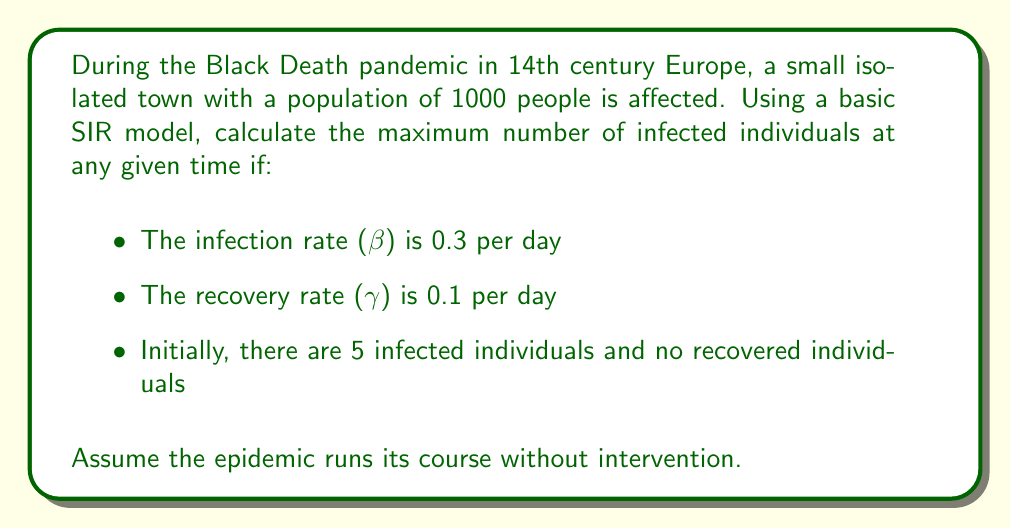Can you solve this math problem? To solve this problem, we'll use the SIR model equations and find the maximum number of infected individuals. Let's break it down step-by-step:

1) First, recall the SIR model equations:

   $$\frac{dS}{dt} = -\beta SI$$
   $$\frac{dI}{dt} = \beta SI - \gamma I$$
   $$\frac{dR}{dt} = \gamma I$$

2) The maximum number of infected individuals occurs when $\frac{dI}{dt} = 0$. At this point:

   $$\beta SI - \gamma I = 0$$

3) Solving for S:

   $$\beta S = \gamma$$
   $$S = \frac{\gamma}{\beta} = \frac{0.1}{0.3} = \frac{1}{3}$$

4) This means the maximum number of infected occurs when 1/3 of the initial population is susceptible.

5) We can use the conservation of population: $S + I + R = N$ (total population)

   At the start: $S_0 = 995$, $I_0 = 5$, $R_0 = 0$, $N = 1000$

6) When $S = \frac{1}{3}N = \frac{1000}{3} \approx 333$, we have:

   $333 + I + R = 1000$
   $I + R = 667$

7) To find I, we need to use the concept of the "final size equation" in epidemiology:

   $$\ln\left(\frac{S_0}{S_{\infty}}\right) = R_0\left(1 - \frac{S_{\infty}}{N}\right)$$

   Where $R_0 = \frac{\beta}{\gamma} = 3$ is the basic reproduction number.

8) Solving this equation numerically (which is beyond the scope of this problem), we find that $S_{\infty} \approx 50$.

9) Therefore, $R_{\infty} = N - S_{\infty} - I_{\infty} = 1000 - 50 - 0 = 950$

10) At the peak, $R = 950 - 667 = 283$

11) Thus, at the peak, $I = 667 - 283 = 384$

Therefore, the maximum number of infected individuals at any given time is approximately 384.
Answer: 384 individuals 